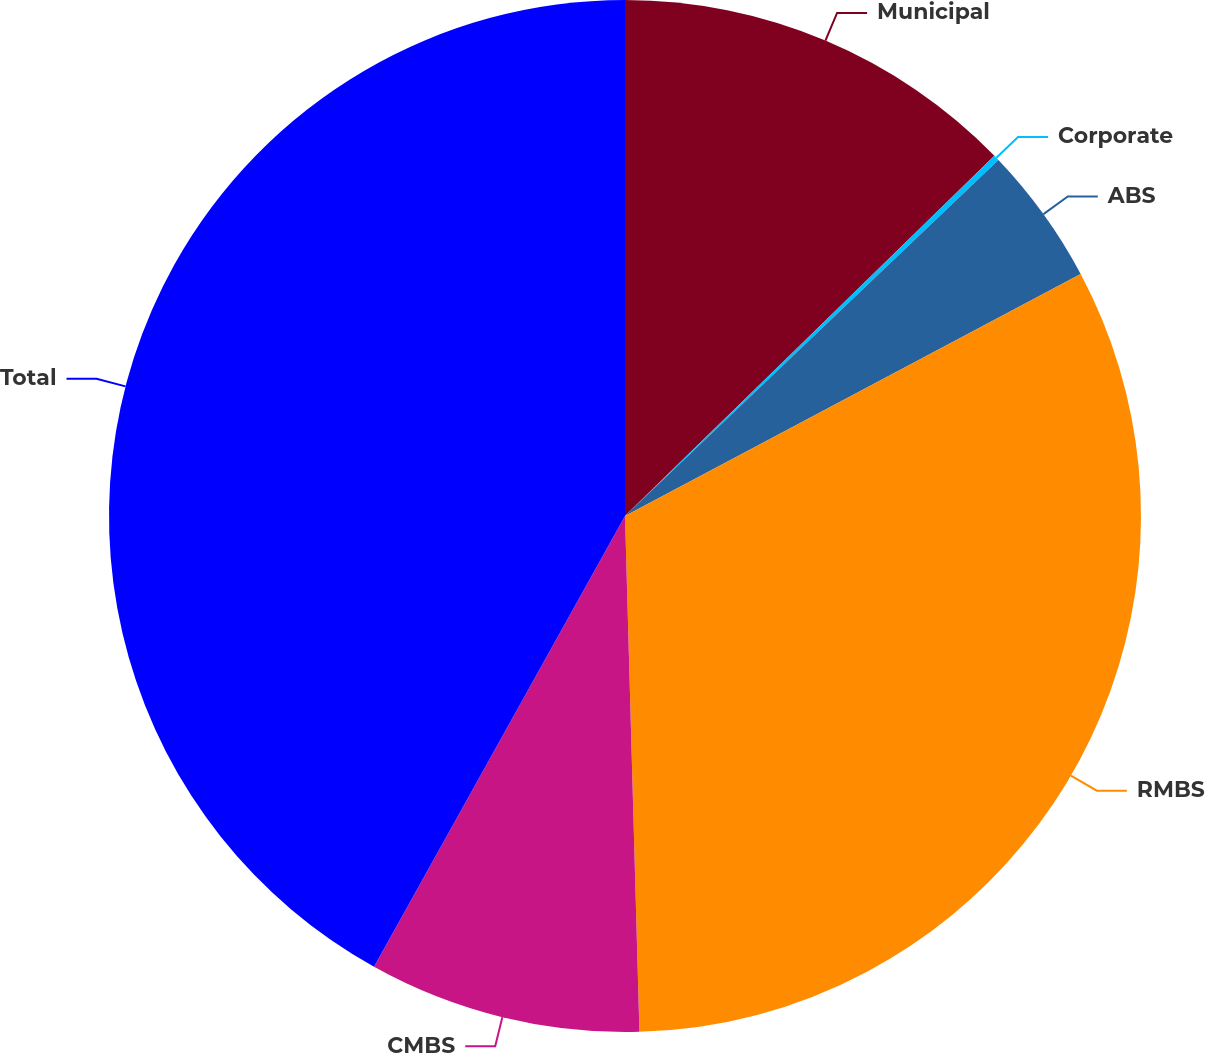Convert chart. <chart><loc_0><loc_0><loc_500><loc_500><pie_chart><fcel>Municipal<fcel>Corporate<fcel>ABS<fcel>RMBS<fcel>CMBS<fcel>Total<nl><fcel>12.7%<fcel>0.18%<fcel>4.35%<fcel>32.33%<fcel>8.53%<fcel>41.92%<nl></chart> 